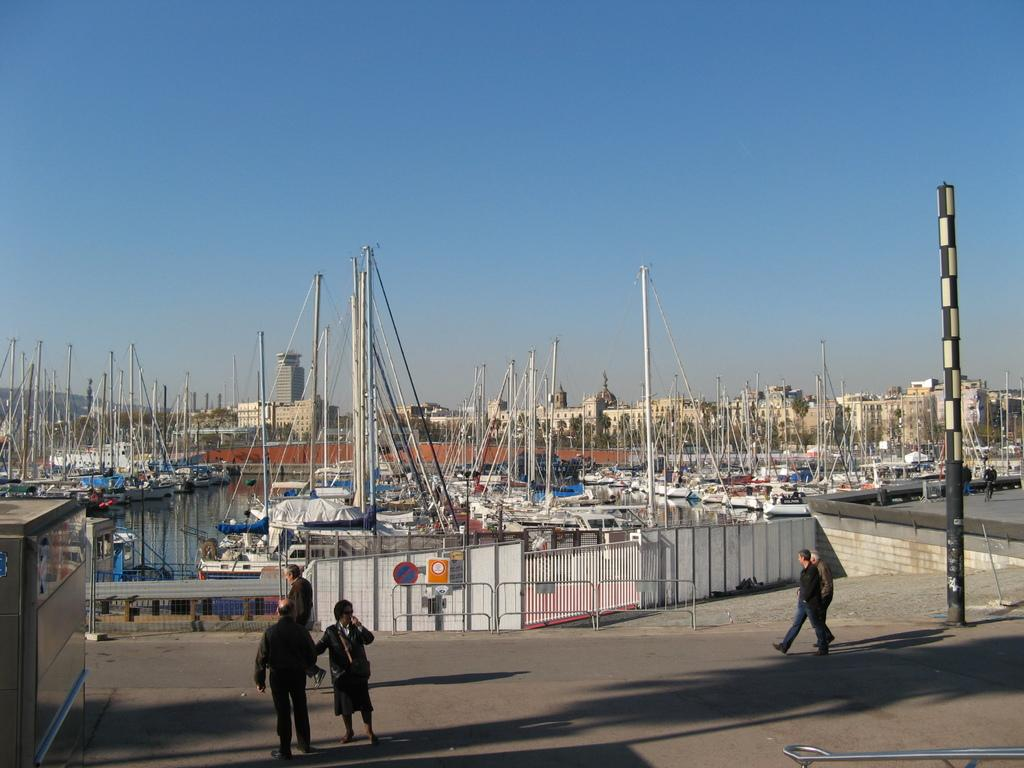How many people are in the image? There are people in the image, but the exact number cannot be determined from the provided facts. What structures can be seen in the image? There are poles, boards, railing, and a fence in the image. What type of vehicles are present in the image? There are boats in the image. What is the condition of the water in the image? Water is visible in the image, but its condition cannot be determined from the provided facts. What can be seen in the background of the image? There are buildings and the blue sky visible in the background of the image. What type of blade is being used to cut the letters in the image? There are no letters or blades present in the image. 